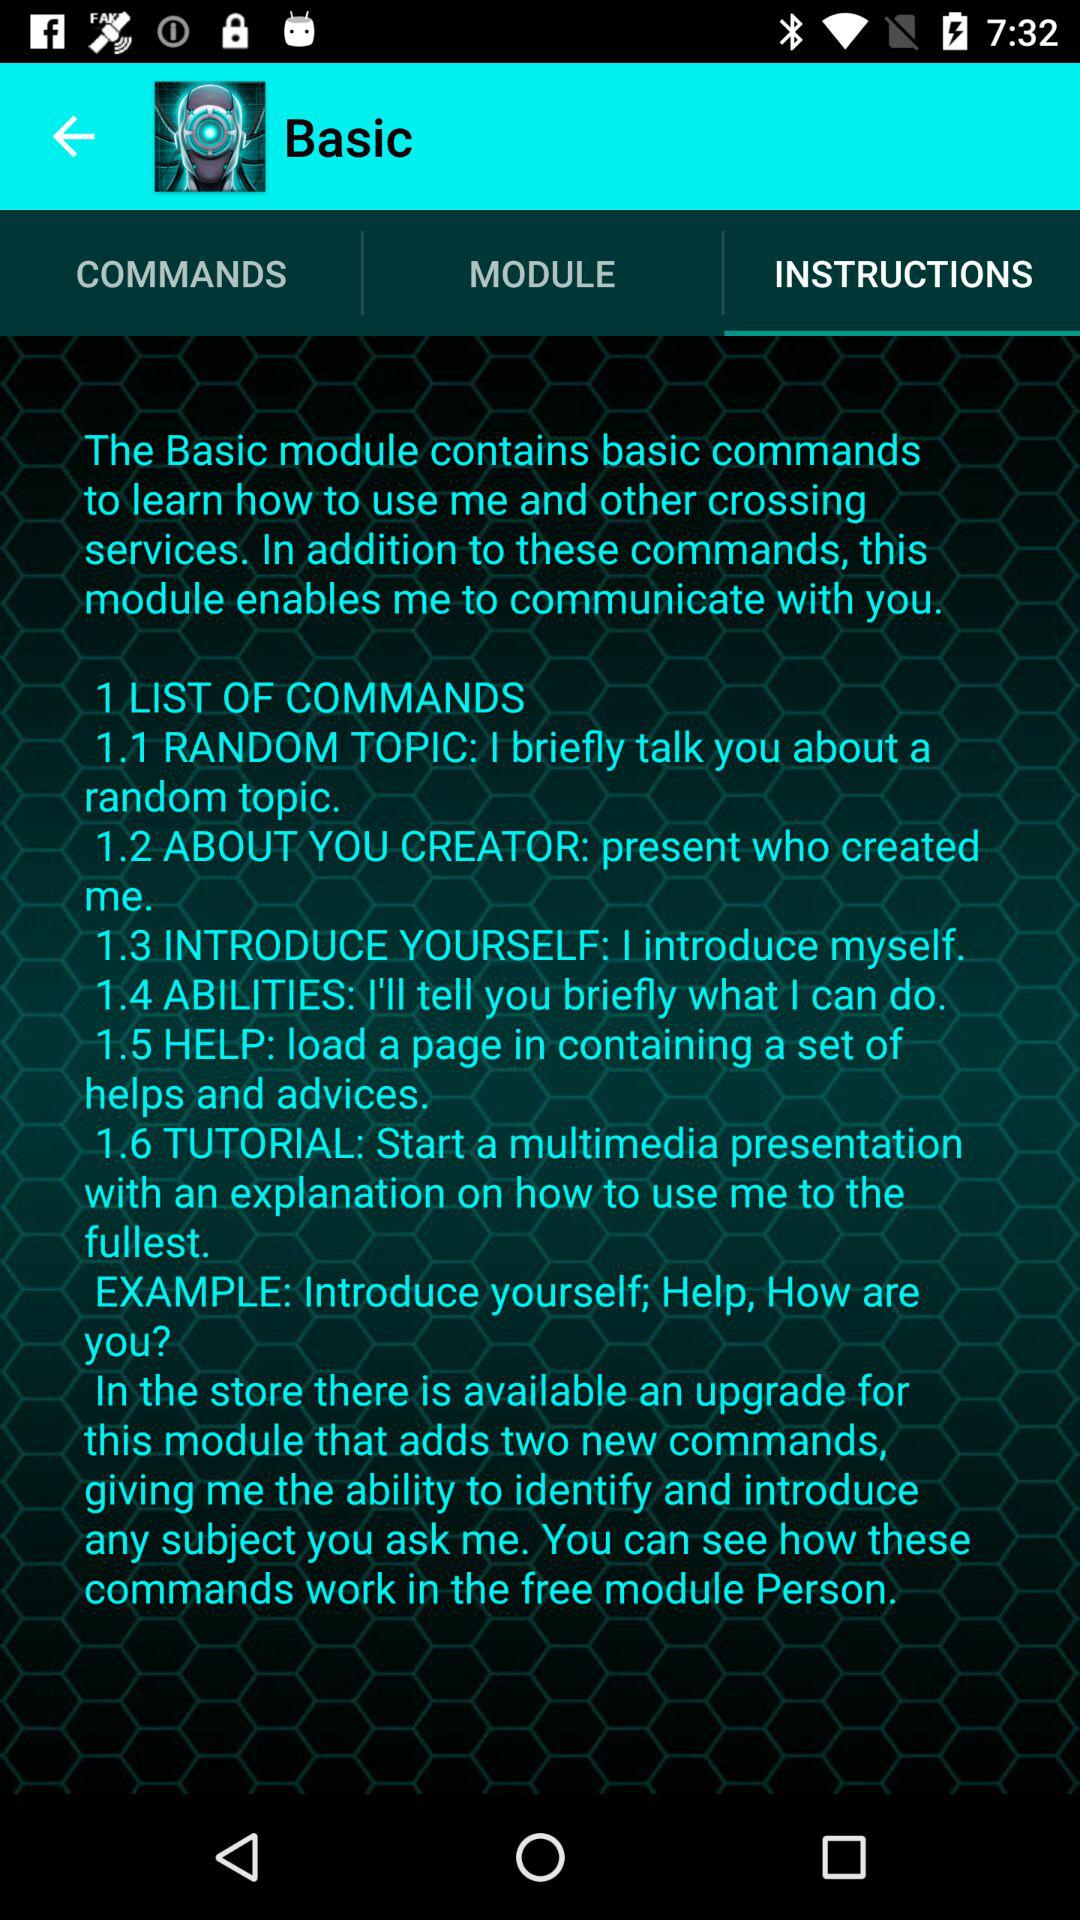Which option is selected? The selected option is "INSTRUCTIONS". 